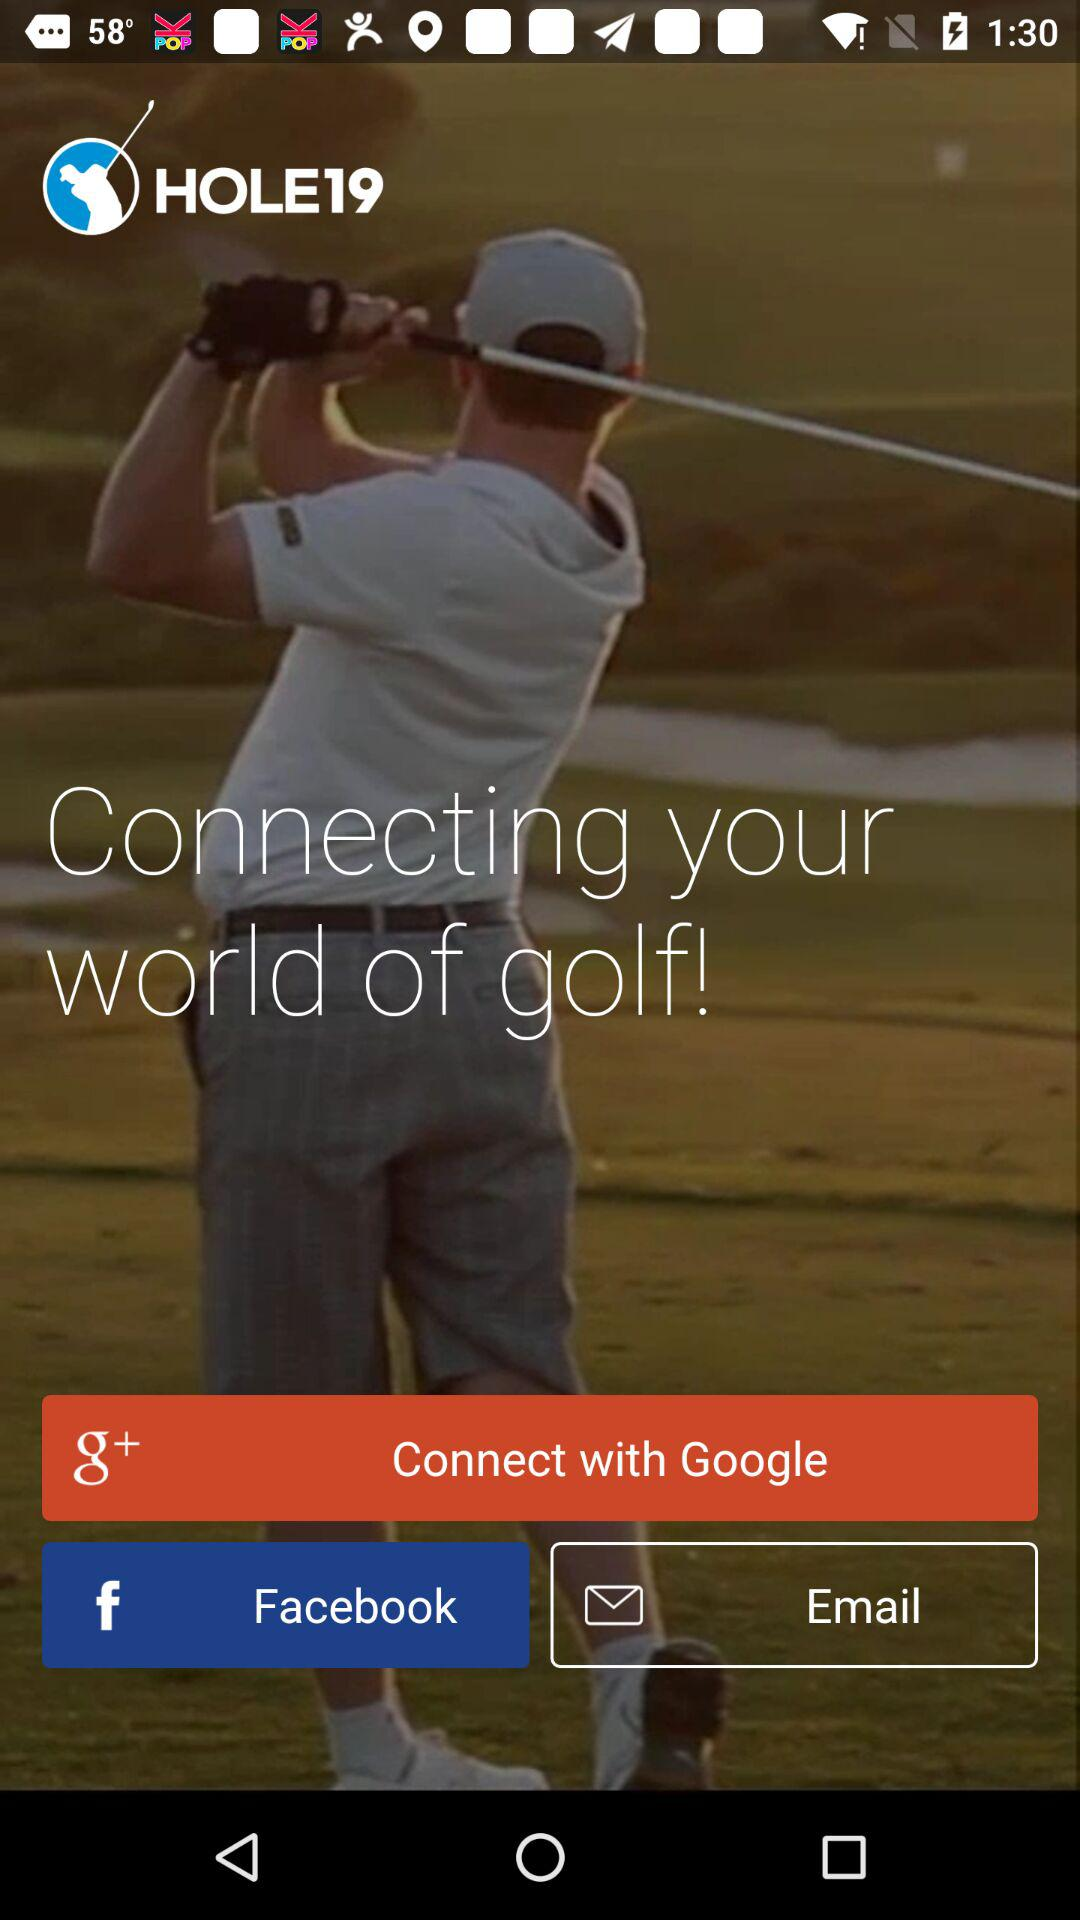What are the options to log in? The options to log in are "Google", "Facebook" and "Email". 